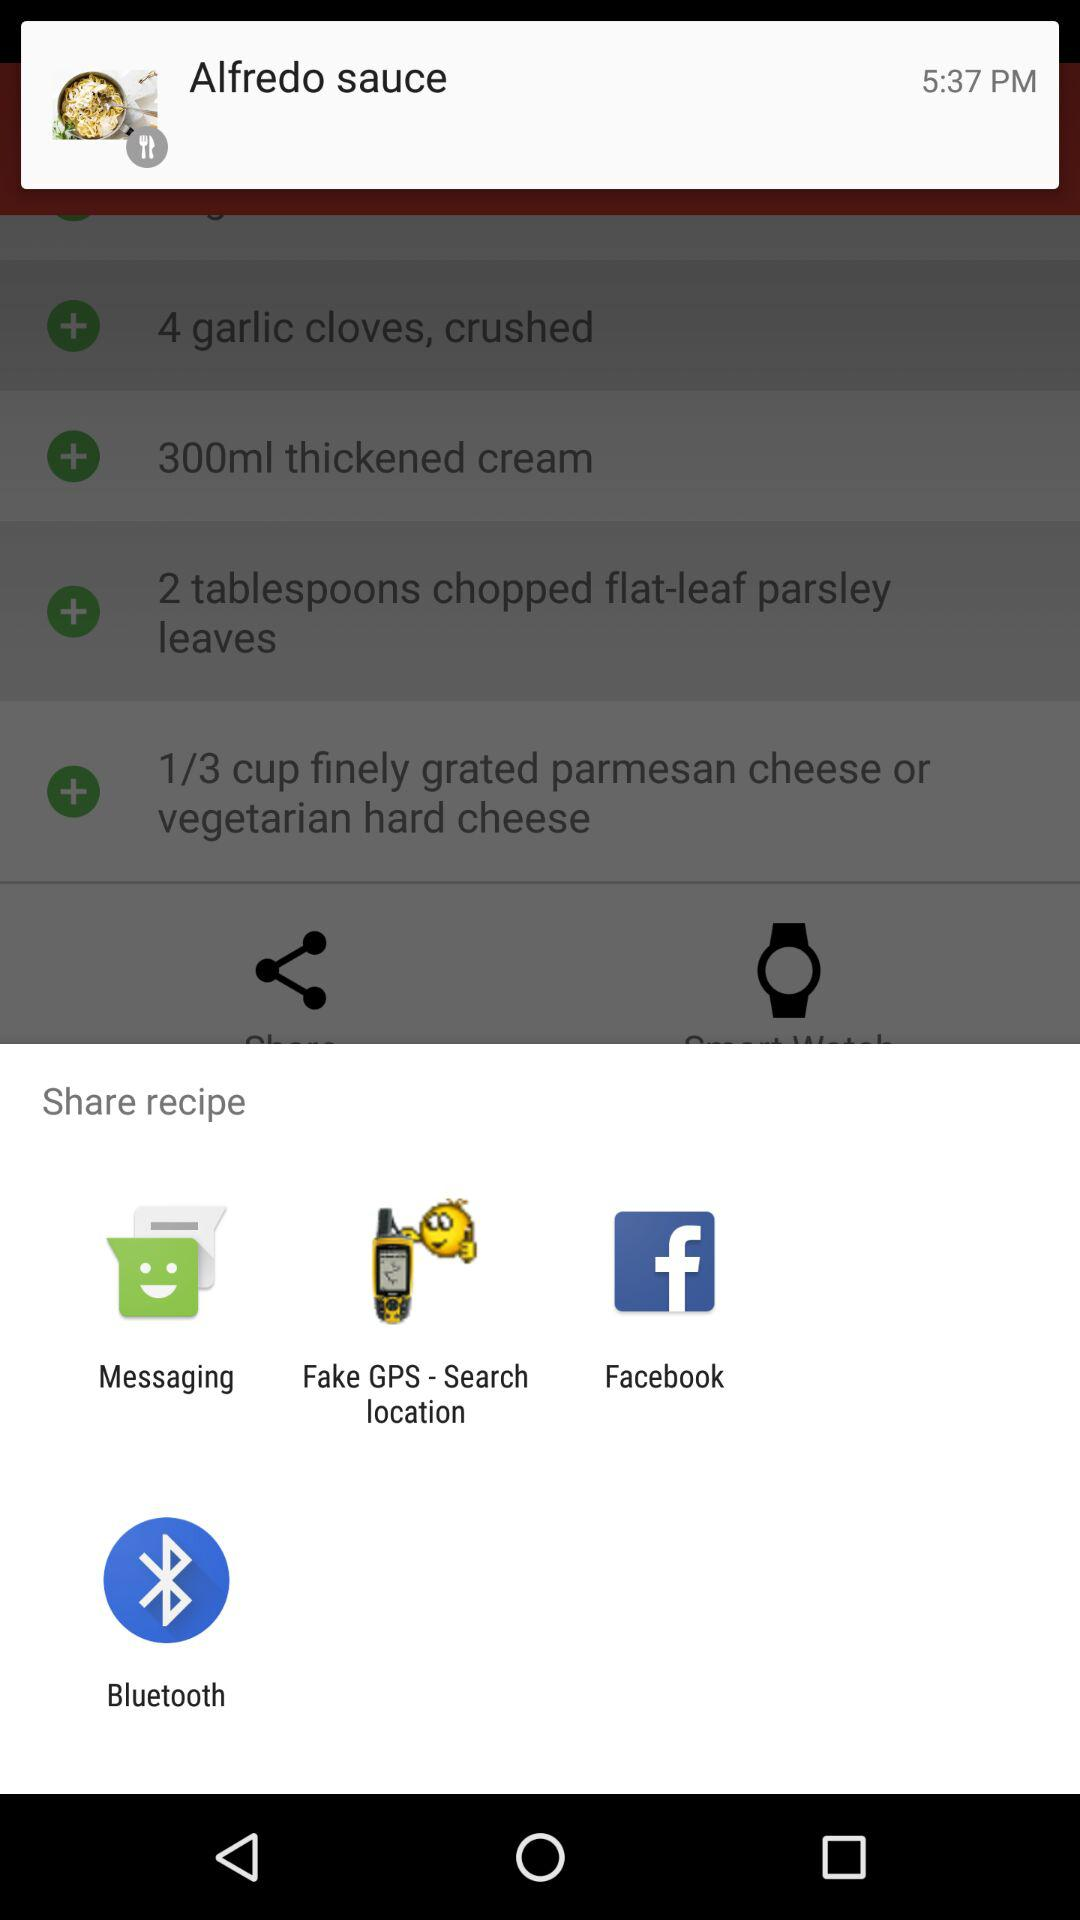How many ingredients are there in this recipe?
Answer the question using a single word or phrase. 4 